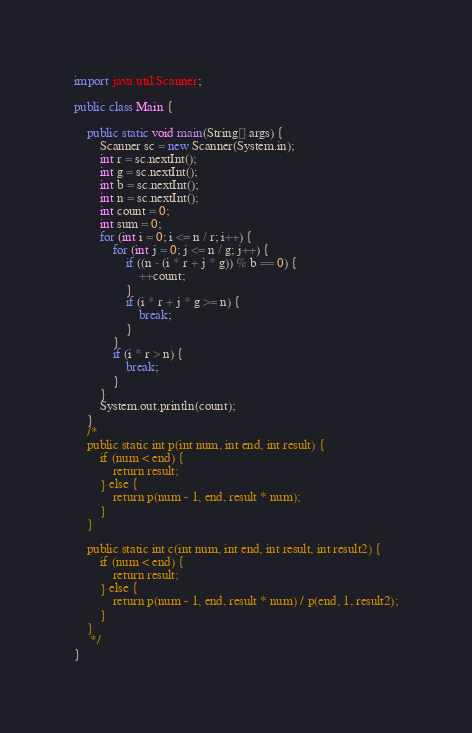<code> <loc_0><loc_0><loc_500><loc_500><_Java_>import java.util.Scanner;

public class Main {
	
	public static void main(String[] args) {
		Scanner sc = new Scanner(System.in);
		int r = sc.nextInt();
		int g = sc.nextInt();
		int b = sc.nextInt();
		int n = sc.nextInt();
		int count = 0;
		int sum = 0;
		for (int i = 0; i <= n / r; i++) {
			for (int j = 0; j <= n / g; j++) {
				if ((n - (i * r + j * g)) % b == 0) {
					++count;
				}
				if (i * r + j * g >= n) {
					break;
				}
			}
			if (i * r > n) {
				break;
			}
		}
		System.out.println(count);
	}
	/*
	public static int p(int num, int end, int result) {
		if (num < end) {
			return result;
		} else {
			return p(num - 1, end, result * num);
		}
	}
	
	public static int c(int num, int end, int result, int result2) {
		if (num < end) {
			return result;
		} else {
			return p(num - 1, end, result * num) / p(end, 1, result2);
		}
	}
	 */
}
</code> 